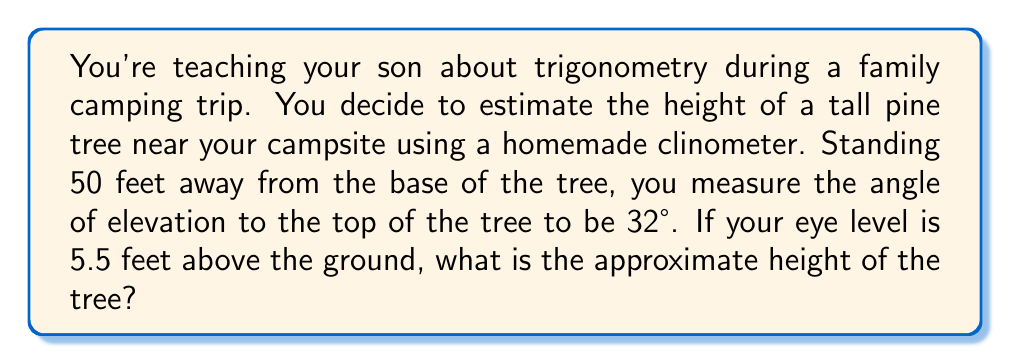Can you solve this math problem? Let's approach this step-by-step:

1) First, let's visualize the problem:

[asy]
import geometry;

size(200);
pair A = (0,0), B = (5,0), C = (5,3), D = (5,3.5);
draw(A--B--C--A);
draw(B--D,dashed);
label("50 ft",A--B,S);
label("Tree",B--C,E);
label("5.5 ft",B--D,E);
label("32°",A,NE);
label("A",A,SW);
label("B",B,SE);
label("C",C,NE);
label("D",D,E);
[/asy]

2) We can break this problem into two parts: the height from the ground to eye level (known), and the height from eye level to the top of the tree (unknown).

3) Let's focus on the right triangle formed by your eye level, the top of the tree, and the ground:

   - The adjacent side is 50 feet (distance from you to the tree)
   - The angle of elevation is 32°
   - We need to find the opposite side (height from eye level to tree top)

4) We can use the tangent function to find this height:

   $\tan(32°) = \frac{\text{opposite}}{\text{adjacent}} = \frac{\text{height above eye level}}{50}$

5) Rearranging this equation:

   $\text{height above eye level} = 50 \times \tan(32°)$

6) Calculate:
   
   $\text{height above eye level} = 50 \times \tan(32°) \approx 50 \times 0.6249 \approx 31.245$ feet

7) Now, we add this to your eye level height:

   $\text{Total height} = 31.245 + 5.5 = 36.745$ feet

8) Rounding to the nearest foot:

   $\text{Total height} \approx 37$ feet
Answer: The approximate height of the tree is 37 feet. 